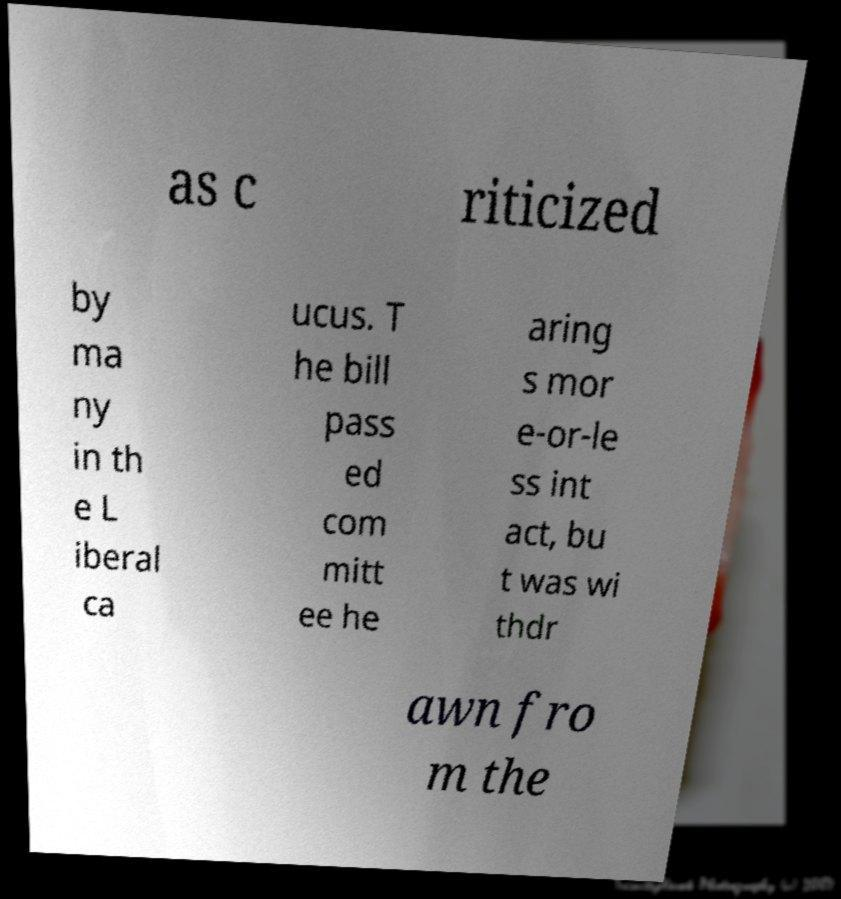I need the written content from this picture converted into text. Can you do that? as c riticized by ma ny in th e L iberal ca ucus. T he bill pass ed com mitt ee he aring s mor e-or-le ss int act, bu t was wi thdr awn fro m the 